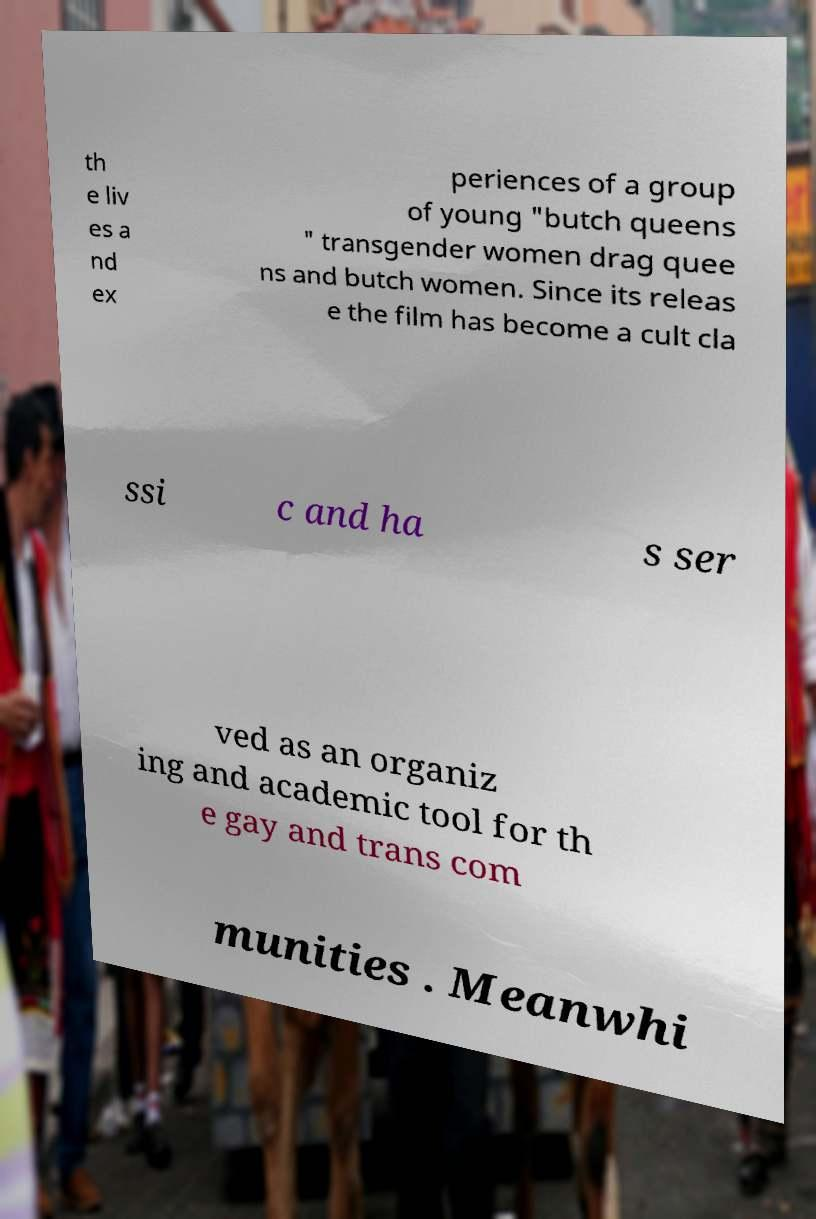Could you assist in decoding the text presented in this image and type it out clearly? th e liv es a nd ex periences of a group of young "butch queens " transgender women drag quee ns and butch women. Since its releas e the film has become a cult cla ssi c and ha s ser ved as an organiz ing and academic tool for th e gay and trans com munities . Meanwhi 